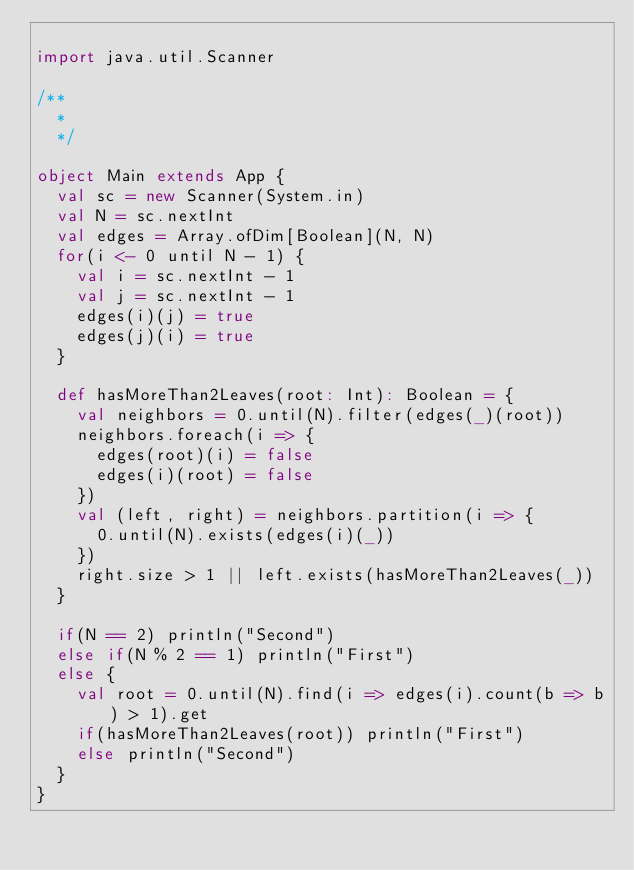Convert code to text. <code><loc_0><loc_0><loc_500><loc_500><_Scala_>
import java.util.Scanner

/**
  *
  */

object Main extends App {
  val sc = new Scanner(System.in)
  val N = sc.nextInt
  val edges = Array.ofDim[Boolean](N, N)
  for(i <- 0 until N - 1) {
    val i = sc.nextInt - 1
    val j = sc.nextInt - 1
    edges(i)(j) = true
    edges(j)(i) = true
  }

  def hasMoreThan2Leaves(root: Int): Boolean = {
    val neighbors = 0.until(N).filter(edges(_)(root))
    neighbors.foreach(i => {
      edges(root)(i) = false
      edges(i)(root) = false
    })
    val (left, right) = neighbors.partition(i => {
      0.until(N).exists(edges(i)(_))
    })
    right.size > 1 || left.exists(hasMoreThan2Leaves(_))
  }

  if(N == 2) println("Second")
  else if(N % 2 == 1) println("First")
  else {
    val root = 0.until(N).find(i => edges(i).count(b => b) > 1).get
    if(hasMoreThan2Leaves(root)) println("First")
    else println("Second")
  }
}</code> 